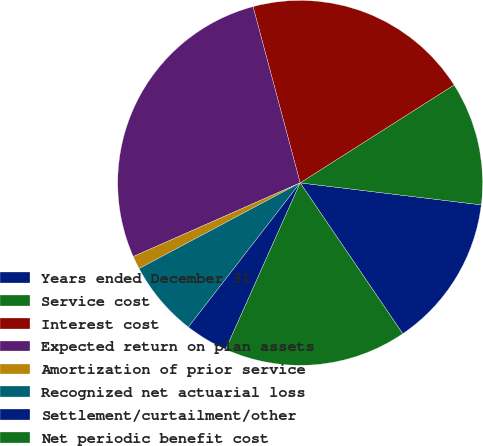<chart> <loc_0><loc_0><loc_500><loc_500><pie_chart><fcel>Years ended December 31<fcel>Service cost<fcel>Interest cost<fcel>Expected return on plan assets<fcel>Amortization of prior service<fcel>Recognized net actuarial loss<fcel>Settlement/curtailment/other<fcel>Net periodic benefit cost<nl><fcel>13.57%<fcel>10.94%<fcel>20.14%<fcel>27.46%<fcel>1.17%<fcel>6.72%<fcel>3.8%<fcel>16.2%<nl></chart> 